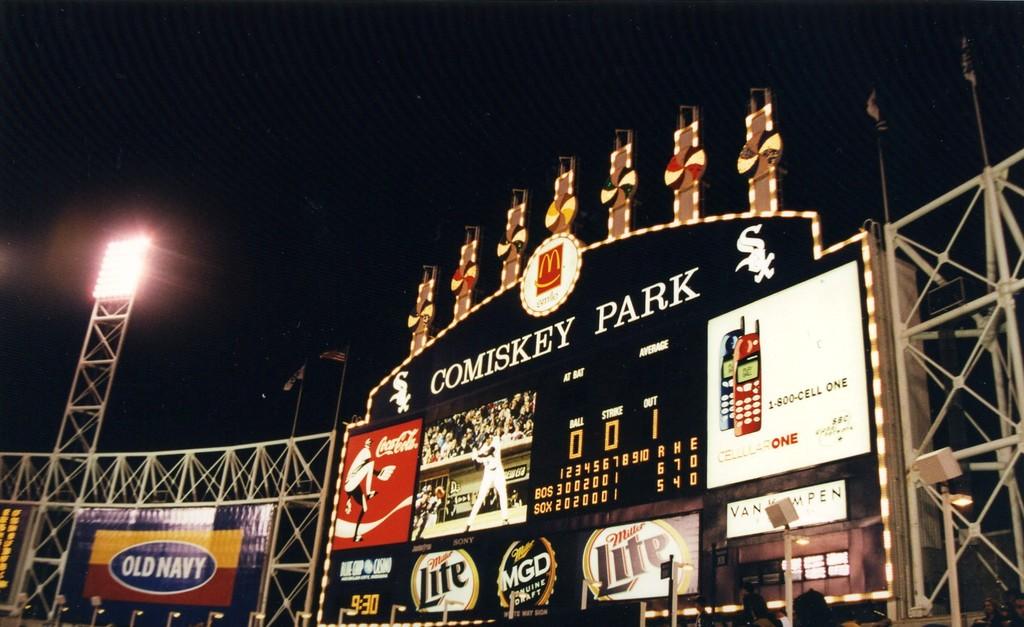They are at the park at what time of day/?
Ensure brevity in your answer.  9:30. 